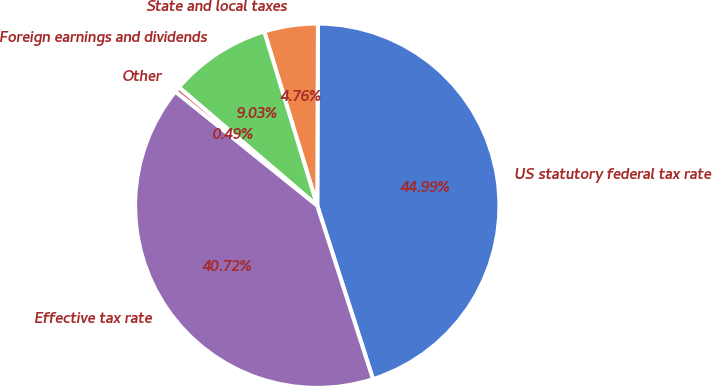Convert chart. <chart><loc_0><loc_0><loc_500><loc_500><pie_chart><fcel>US statutory federal tax rate<fcel>State and local taxes<fcel>Foreign earnings and dividends<fcel>Other<fcel>Effective tax rate<nl><fcel>44.99%<fcel>4.76%<fcel>9.03%<fcel>0.49%<fcel>40.72%<nl></chart> 